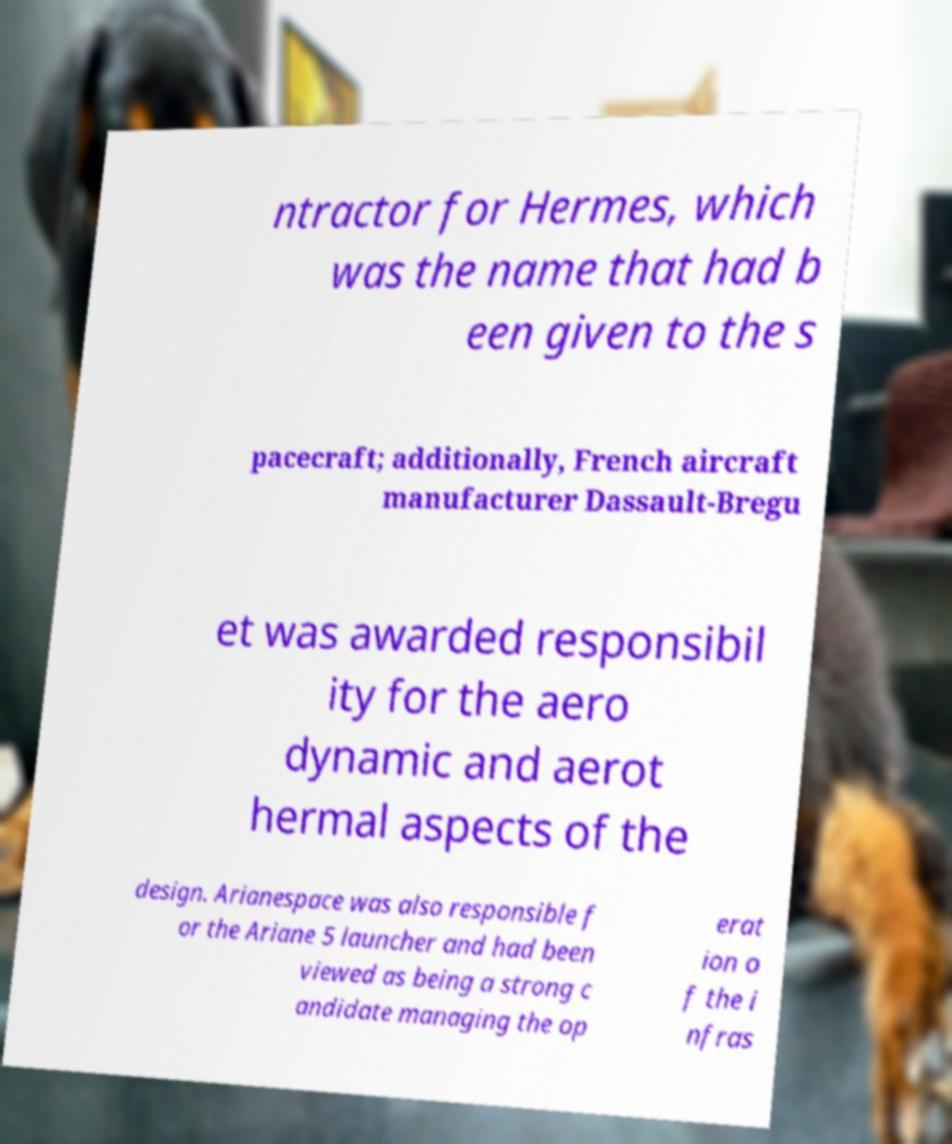Please read and relay the text visible in this image. What does it say? ntractor for Hermes, which was the name that had b een given to the s pacecraft; additionally, French aircraft manufacturer Dassault-Bregu et was awarded responsibil ity for the aero dynamic and aerot hermal aspects of the design. Arianespace was also responsible f or the Ariane 5 launcher and had been viewed as being a strong c andidate managing the op erat ion o f the i nfras 